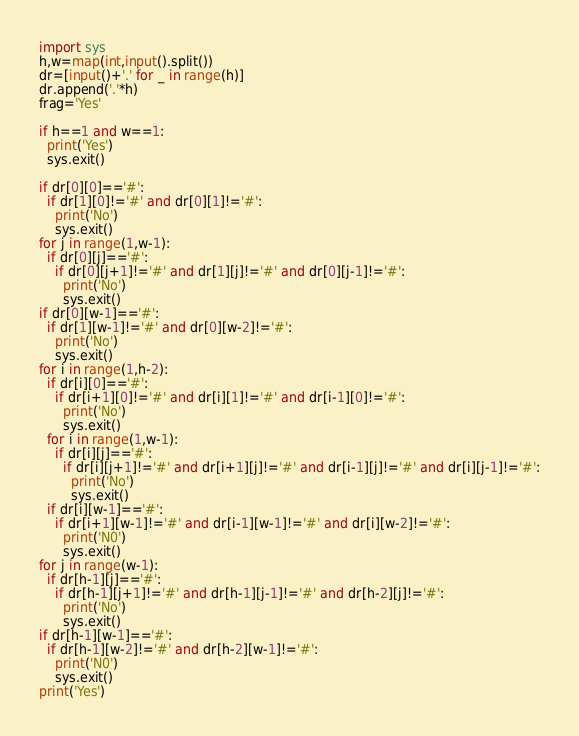Convert code to text. <code><loc_0><loc_0><loc_500><loc_500><_Python_>import sys
h,w=map(int,input().split())
dr=[input()+'.' for _ in range(h)]
dr.append('.'*h)
frag='Yes'

if h==1 and w==1:
  print('Yes')
  sys.exit()

if dr[0][0]=='#':
  if dr[1][0]!='#' and dr[0][1]!='#':
    print('No')
    sys.exit()
for j in range(1,w-1):
  if dr[0][j]=='#':
    if dr[0][j+1]!='#' and dr[1][j]!='#' and dr[0][j-1]!='#':
      print('No')
      sys.exit()
if dr[0][w-1]=='#':
  if dr[1][w-1]!='#' and dr[0][w-2]!='#':
    print('No')
    sys.exit()
for i in range(1,h-2):
  if dr[i][0]=='#':
    if dr[i+1][0]!='#' and dr[i][1]!='#' and dr[i-1][0]!='#':
      print('No')
      sys.exit()
  for i in range(1,w-1):
    if dr[i][j]=='#':
      if dr[i][j+1]!='#' and dr[i+1][j]!='#' and dr[i-1][j]!='#' and dr[i][j-1]!='#':
        print('No')
        sys.exit()
  if dr[i][w-1]=='#':
    if dr[i+1][w-1]!='#' and dr[i-1][w-1]!='#' and dr[i][w-2]!='#':
      print('N0')
      sys.exit()
for j in range(w-1):
  if dr[h-1][j]=='#':
    if dr[h-1][j+1]!='#' and dr[h-1][j-1]!='#' and dr[h-2][j]!='#':
      print('No')
      sys.exit()
if dr[h-1][w-1]=='#':
  if dr[h-1][w-2]!='#' and dr[h-2][w-1]!='#':
    print('N0')
    sys.exit()
print('Yes')</code> 